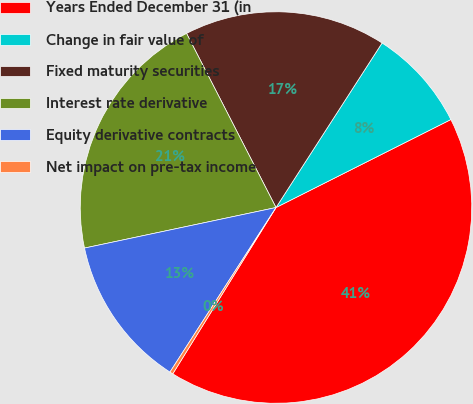Convert chart. <chart><loc_0><loc_0><loc_500><loc_500><pie_chart><fcel>Years Ended December 31 (in<fcel>Change in fair value of<fcel>Fixed maturity securities<fcel>Interest rate derivative<fcel>Equity derivative contracts<fcel>Net impact on pre-tax income<nl><fcel>41.27%<fcel>8.47%<fcel>16.67%<fcel>20.77%<fcel>12.57%<fcel>0.27%<nl></chart> 